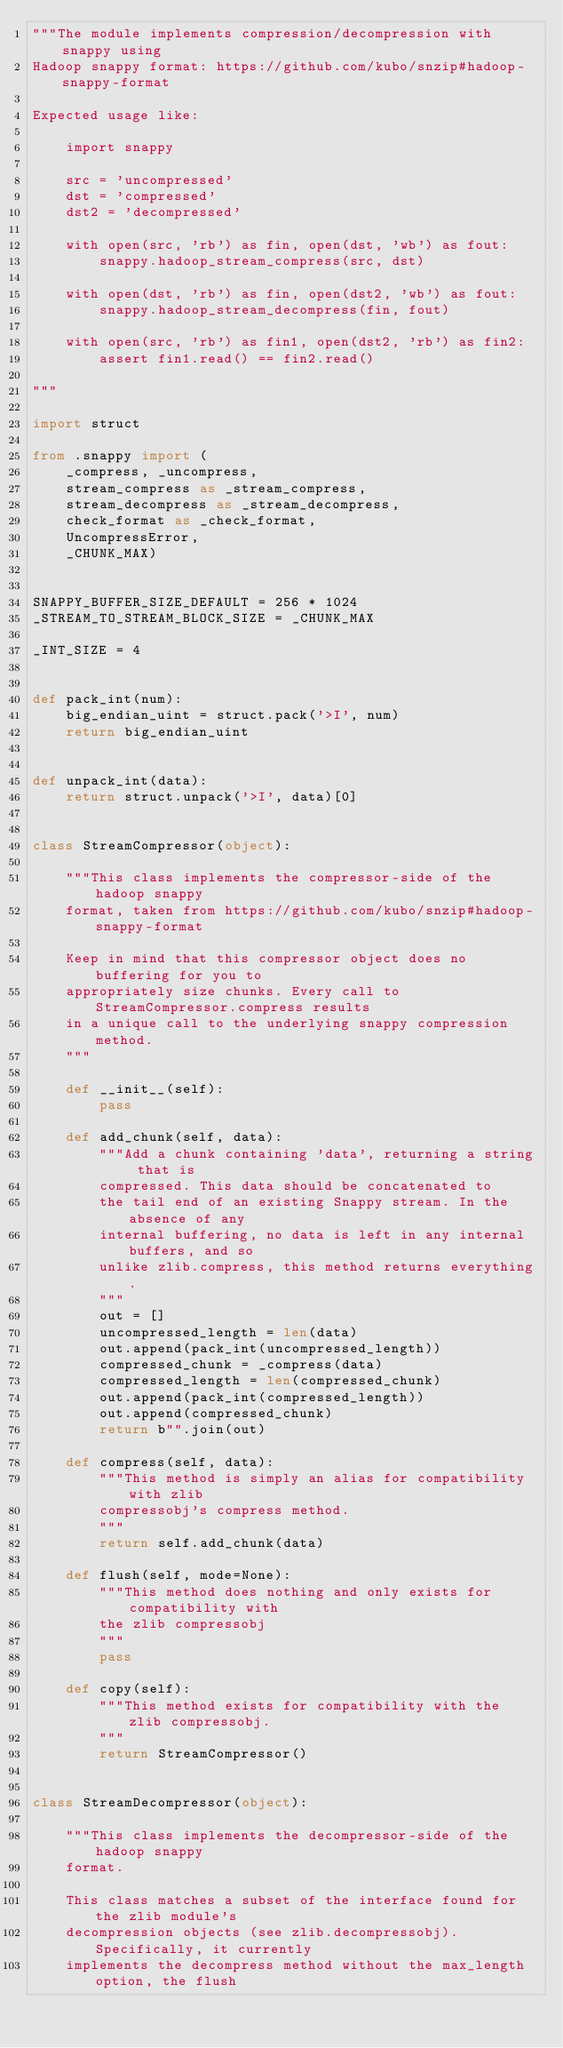<code> <loc_0><loc_0><loc_500><loc_500><_Python_>"""The module implements compression/decompression with snappy using
Hadoop snappy format: https://github.com/kubo/snzip#hadoop-snappy-format

Expected usage like:

    import snappy

    src = 'uncompressed'
    dst = 'compressed'
    dst2 = 'decompressed'

    with open(src, 'rb') as fin, open(dst, 'wb') as fout:
        snappy.hadoop_stream_compress(src, dst)

    with open(dst, 'rb') as fin, open(dst2, 'wb') as fout:
        snappy.hadoop_stream_decompress(fin, fout)

    with open(src, 'rb') as fin1, open(dst2, 'rb') as fin2:
        assert fin1.read() == fin2.read()

"""

import struct

from .snappy import (
    _compress, _uncompress,
    stream_compress as _stream_compress,
    stream_decompress as _stream_decompress,
    check_format as _check_format,
    UncompressError,
    _CHUNK_MAX)


SNAPPY_BUFFER_SIZE_DEFAULT = 256 * 1024
_STREAM_TO_STREAM_BLOCK_SIZE = _CHUNK_MAX

_INT_SIZE = 4


def pack_int(num):
    big_endian_uint = struct.pack('>I', num)
    return big_endian_uint


def unpack_int(data):
    return struct.unpack('>I', data)[0]


class StreamCompressor(object):

    """This class implements the compressor-side of the hadoop snappy
    format, taken from https://github.com/kubo/snzip#hadoop-snappy-format

    Keep in mind that this compressor object does no buffering for you to
    appropriately size chunks. Every call to StreamCompressor.compress results
    in a unique call to the underlying snappy compression method.
    """

    def __init__(self):
        pass

    def add_chunk(self, data):
        """Add a chunk containing 'data', returning a string that is
        compressed. This data should be concatenated to
        the tail end of an existing Snappy stream. In the absence of any
        internal buffering, no data is left in any internal buffers, and so
        unlike zlib.compress, this method returns everything.
        """
        out = []
        uncompressed_length = len(data)
        out.append(pack_int(uncompressed_length))
        compressed_chunk = _compress(data)
        compressed_length = len(compressed_chunk)
        out.append(pack_int(compressed_length))
        out.append(compressed_chunk)
        return b"".join(out)

    def compress(self, data):
        """This method is simply an alias for compatibility with zlib
        compressobj's compress method.
        """
        return self.add_chunk(data)

    def flush(self, mode=None):
        """This method does nothing and only exists for compatibility with
        the zlib compressobj
        """
        pass

    def copy(self):
        """This method exists for compatibility with the zlib compressobj.
        """
        return StreamCompressor()


class StreamDecompressor(object):

    """This class implements the decompressor-side of the hadoop snappy
    format.

    This class matches a subset of the interface found for the zlib module's
    decompression objects (see zlib.decompressobj). Specifically, it currently
    implements the decompress method without the max_length option, the flush</code> 